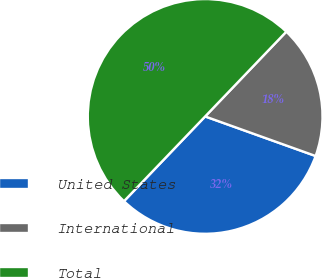Convert chart to OTSL. <chart><loc_0><loc_0><loc_500><loc_500><pie_chart><fcel>United States<fcel>International<fcel>Total<nl><fcel>31.68%<fcel>18.32%<fcel>50.0%<nl></chart> 